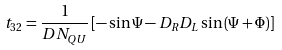Convert formula to latex. <formula><loc_0><loc_0><loc_500><loc_500>t _ { 3 2 } = \frac { 1 } { D N _ { Q U } } \left [ - \sin \Psi - D _ { R } D _ { L } \sin \left ( \Psi + \Phi \right ) \right ]</formula> 